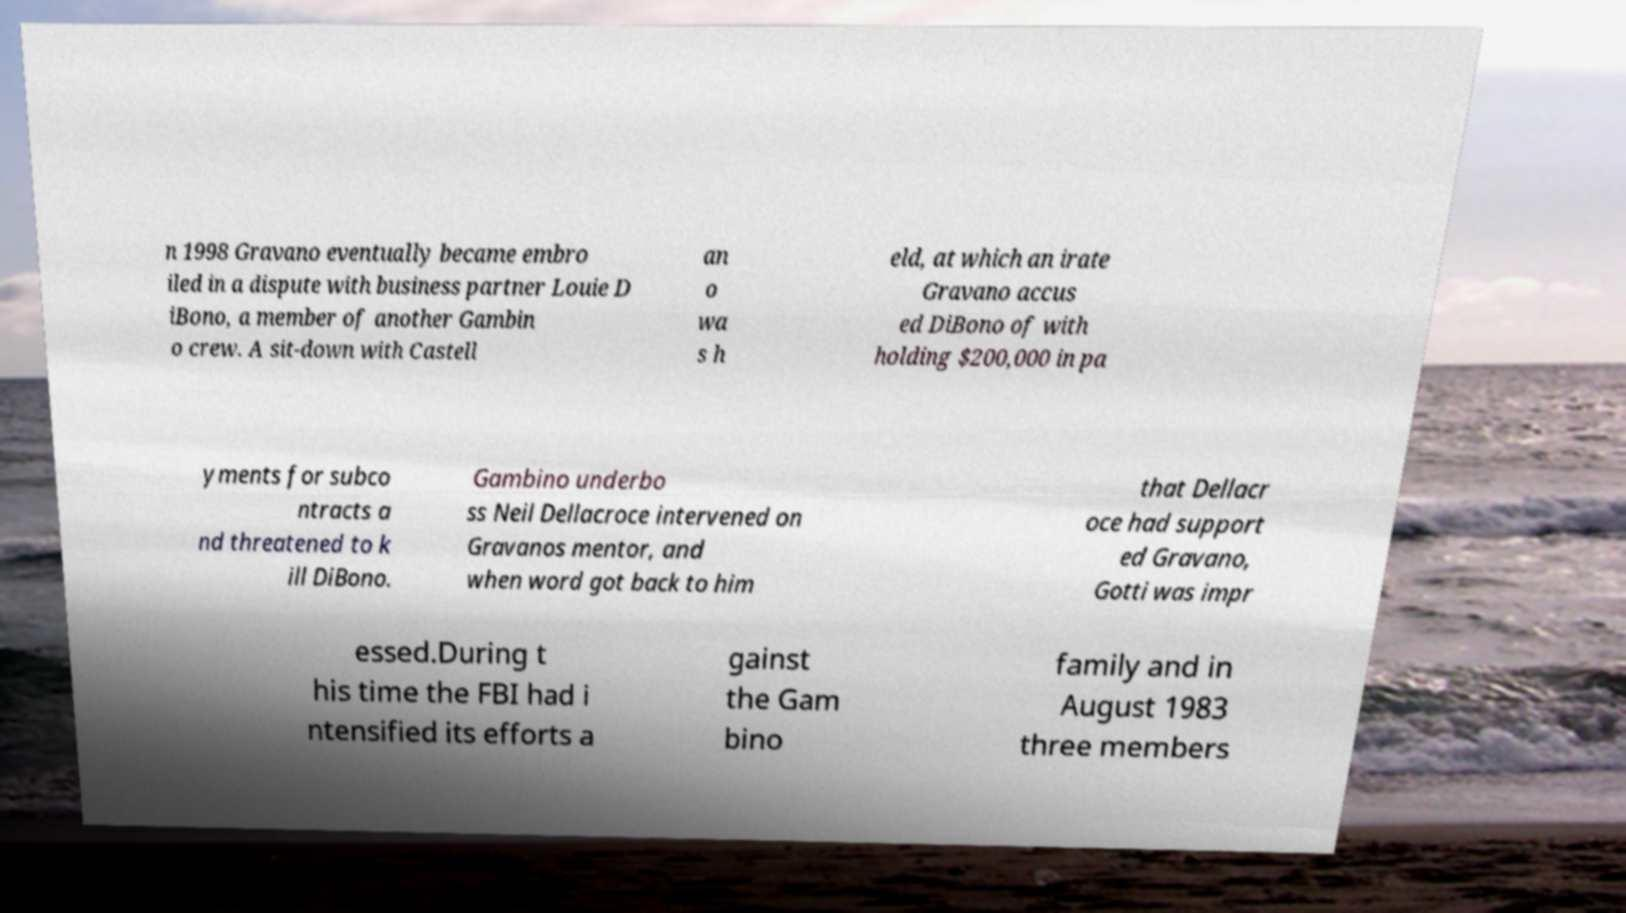Please identify and transcribe the text found in this image. n 1998 Gravano eventually became embro iled in a dispute with business partner Louie D iBono, a member of another Gambin o crew. A sit-down with Castell an o wa s h eld, at which an irate Gravano accus ed DiBono of with holding $200,000 in pa yments for subco ntracts a nd threatened to k ill DiBono. Gambino underbo ss Neil Dellacroce intervened on Gravanos mentor, and when word got back to him that Dellacr oce had support ed Gravano, Gotti was impr essed.During t his time the FBI had i ntensified its efforts a gainst the Gam bino family and in August 1983 three members 